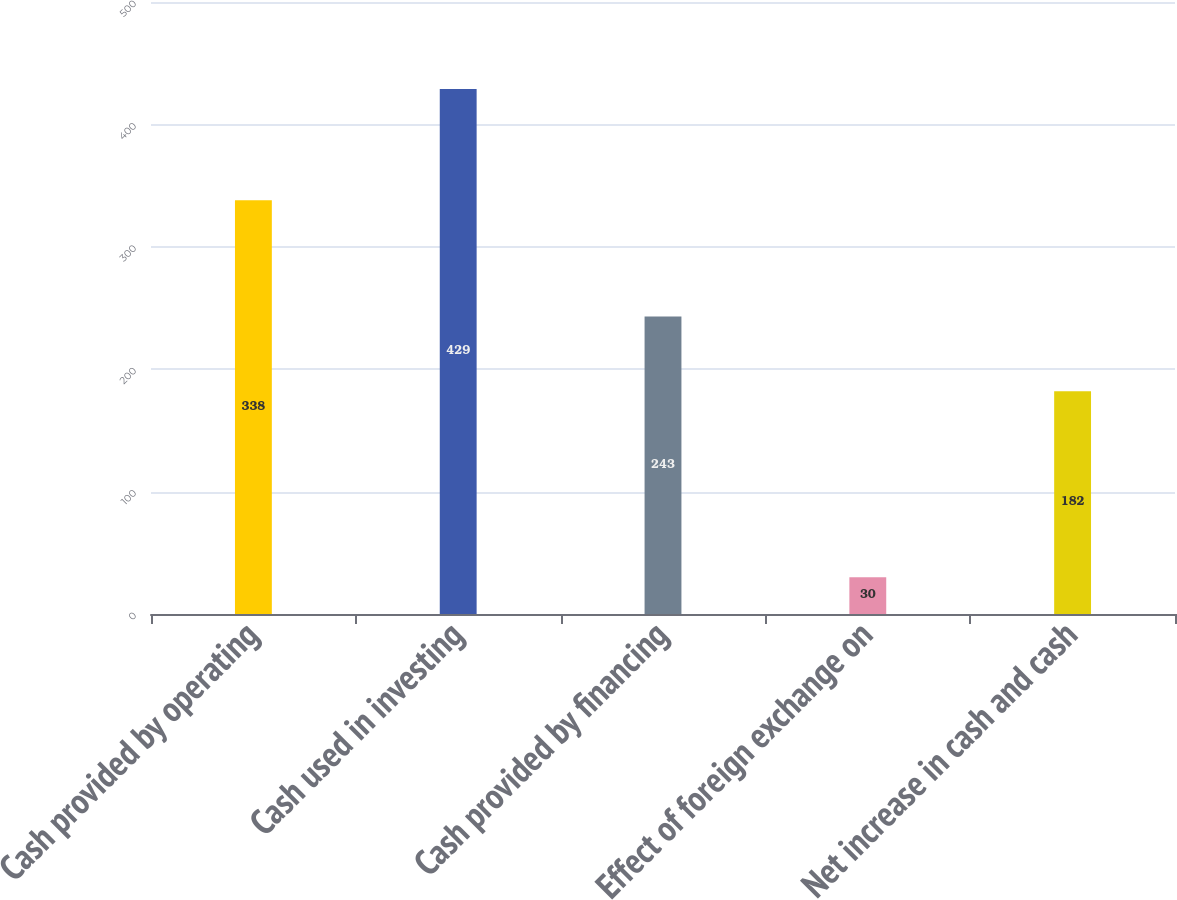Convert chart. <chart><loc_0><loc_0><loc_500><loc_500><bar_chart><fcel>Cash provided by operating<fcel>Cash used in investing<fcel>Cash provided by financing<fcel>Effect of foreign exchange on<fcel>Net increase in cash and cash<nl><fcel>338<fcel>429<fcel>243<fcel>30<fcel>182<nl></chart> 